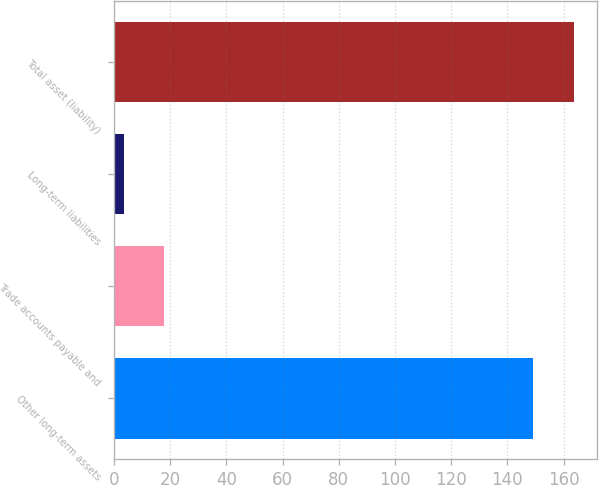Convert chart to OTSL. <chart><loc_0><loc_0><loc_500><loc_500><bar_chart><fcel>Other long-term assets<fcel>Trade accounts payable and<fcel>Long-term liabilities<fcel>Total asset (liability)<nl><fcel>149<fcel>17.91<fcel>3.34<fcel>163.57<nl></chart> 